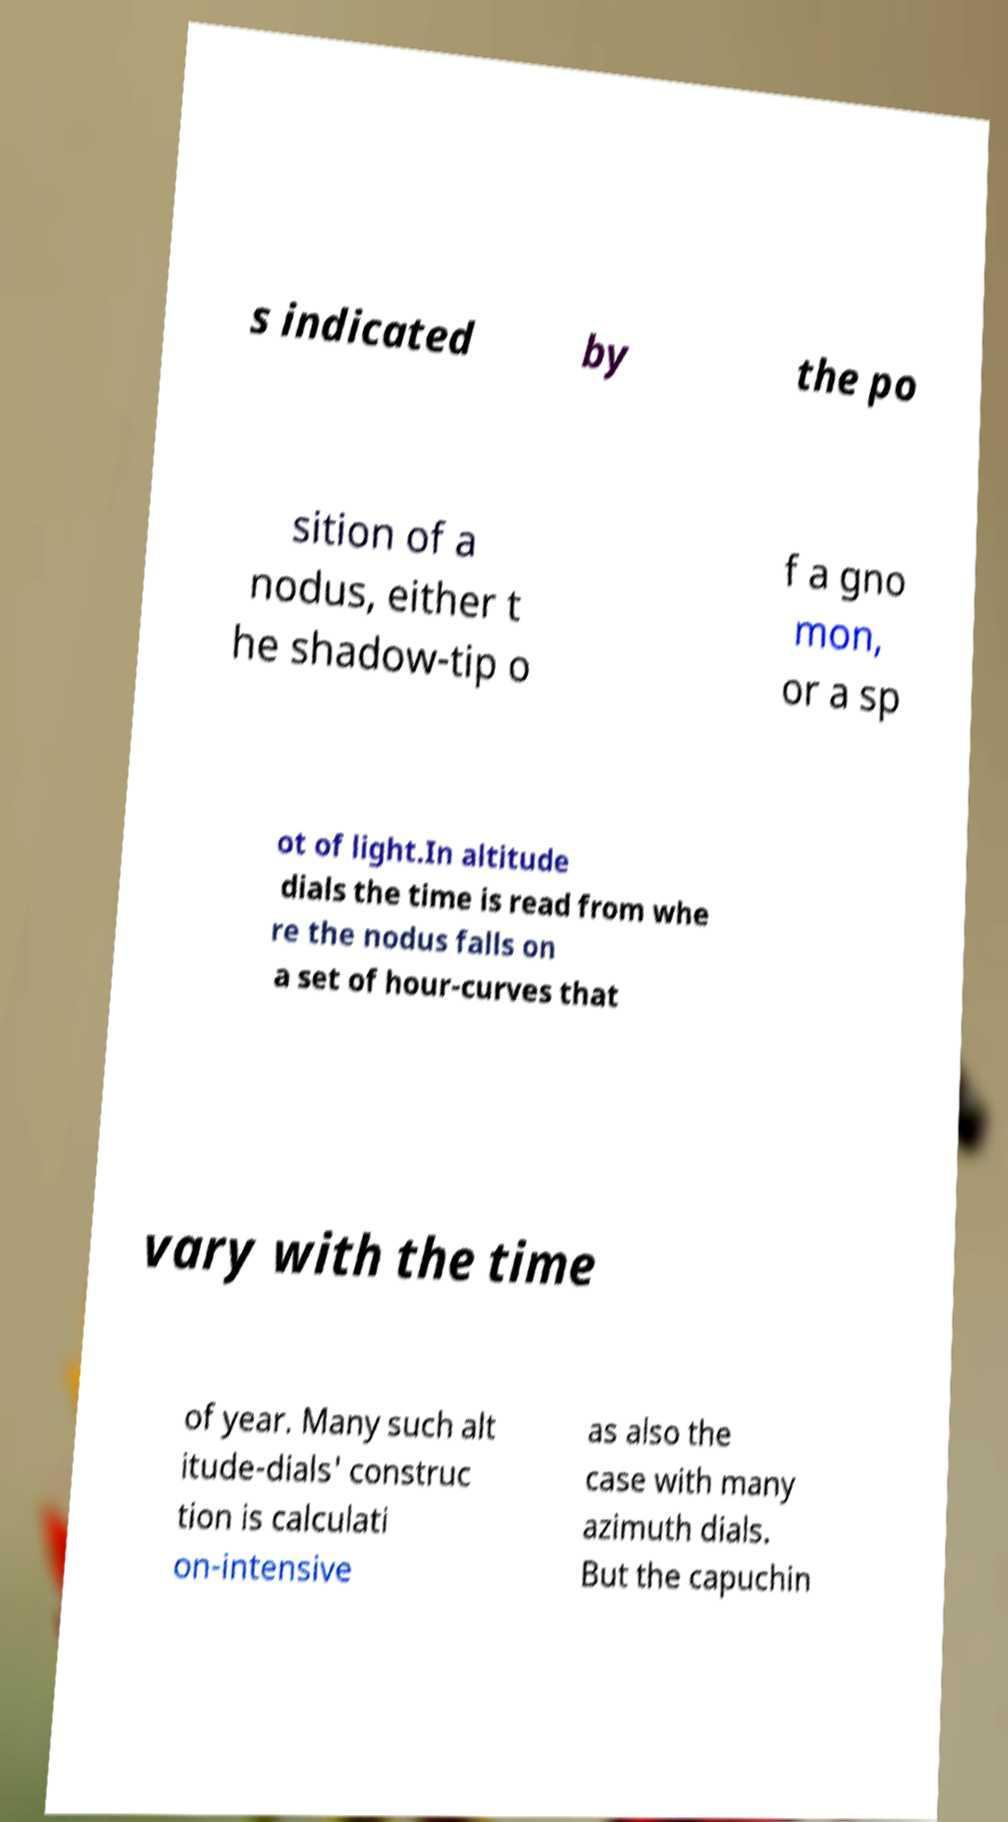For documentation purposes, I need the text within this image transcribed. Could you provide that? s indicated by the po sition of a nodus, either t he shadow-tip o f a gno mon, or a sp ot of light.In altitude dials the time is read from whe re the nodus falls on a set of hour-curves that vary with the time of year. Many such alt itude-dials' construc tion is calculati on-intensive as also the case with many azimuth dials. But the capuchin 